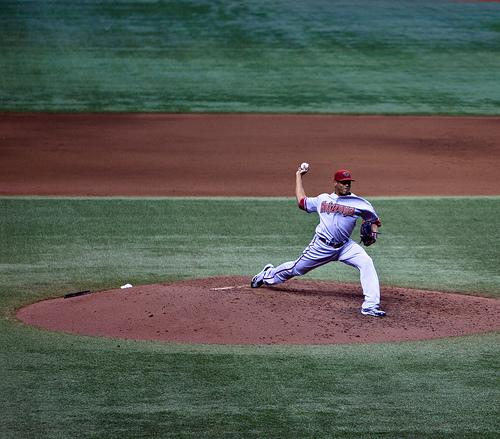Question: where is the baseball glove?
Choices:
A. Laying on the ground.
B. On the shelf.
C. In the man's left hand.
D. On the bench.
Answer with the letter. Answer: C Question: what does it say on the man's shirt?
Choices:
A. Colorado.
B. Arizona.
C. Alabama.
D. Kentucky.
Answer with the letter. Answer: B Question: where was this picture taken?
Choices:
A. At a baseball game.
B. At a party.
C. At an amusement park.
D. At a concert.
Answer with the letter. Answer: A 